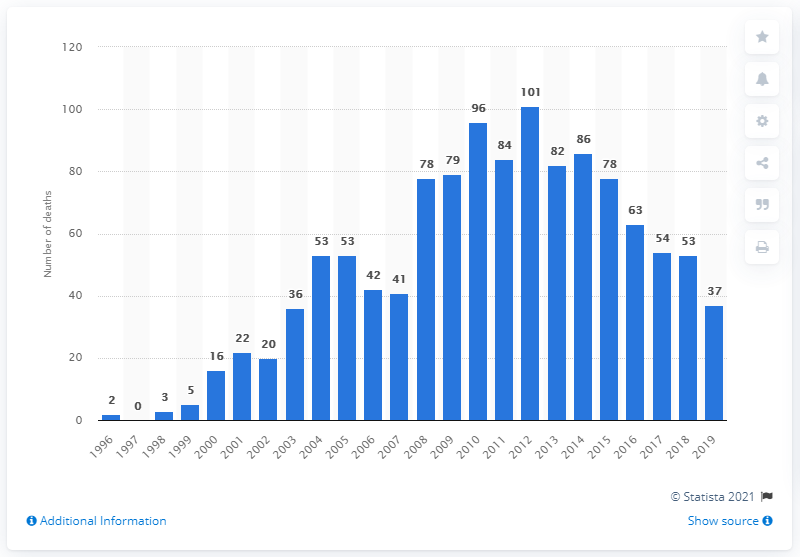Outline some significant characteristics in this image. In 2019, a total of 37 deaths were attributed to the use of citalopram. In 2012, there were 101 deaths related to the use of citalopram. 